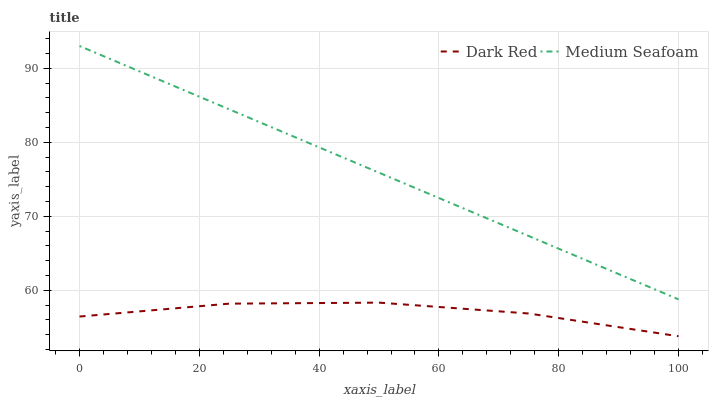Does Dark Red have the minimum area under the curve?
Answer yes or no. Yes. Does Medium Seafoam have the maximum area under the curve?
Answer yes or no. Yes. Does Medium Seafoam have the minimum area under the curve?
Answer yes or no. No. Is Medium Seafoam the smoothest?
Answer yes or no. Yes. Is Dark Red the roughest?
Answer yes or no. Yes. Is Medium Seafoam the roughest?
Answer yes or no. No. Does Dark Red have the lowest value?
Answer yes or no. Yes. Does Medium Seafoam have the lowest value?
Answer yes or no. No. Does Medium Seafoam have the highest value?
Answer yes or no. Yes. Is Dark Red less than Medium Seafoam?
Answer yes or no. Yes. Is Medium Seafoam greater than Dark Red?
Answer yes or no. Yes. Does Dark Red intersect Medium Seafoam?
Answer yes or no. No. 